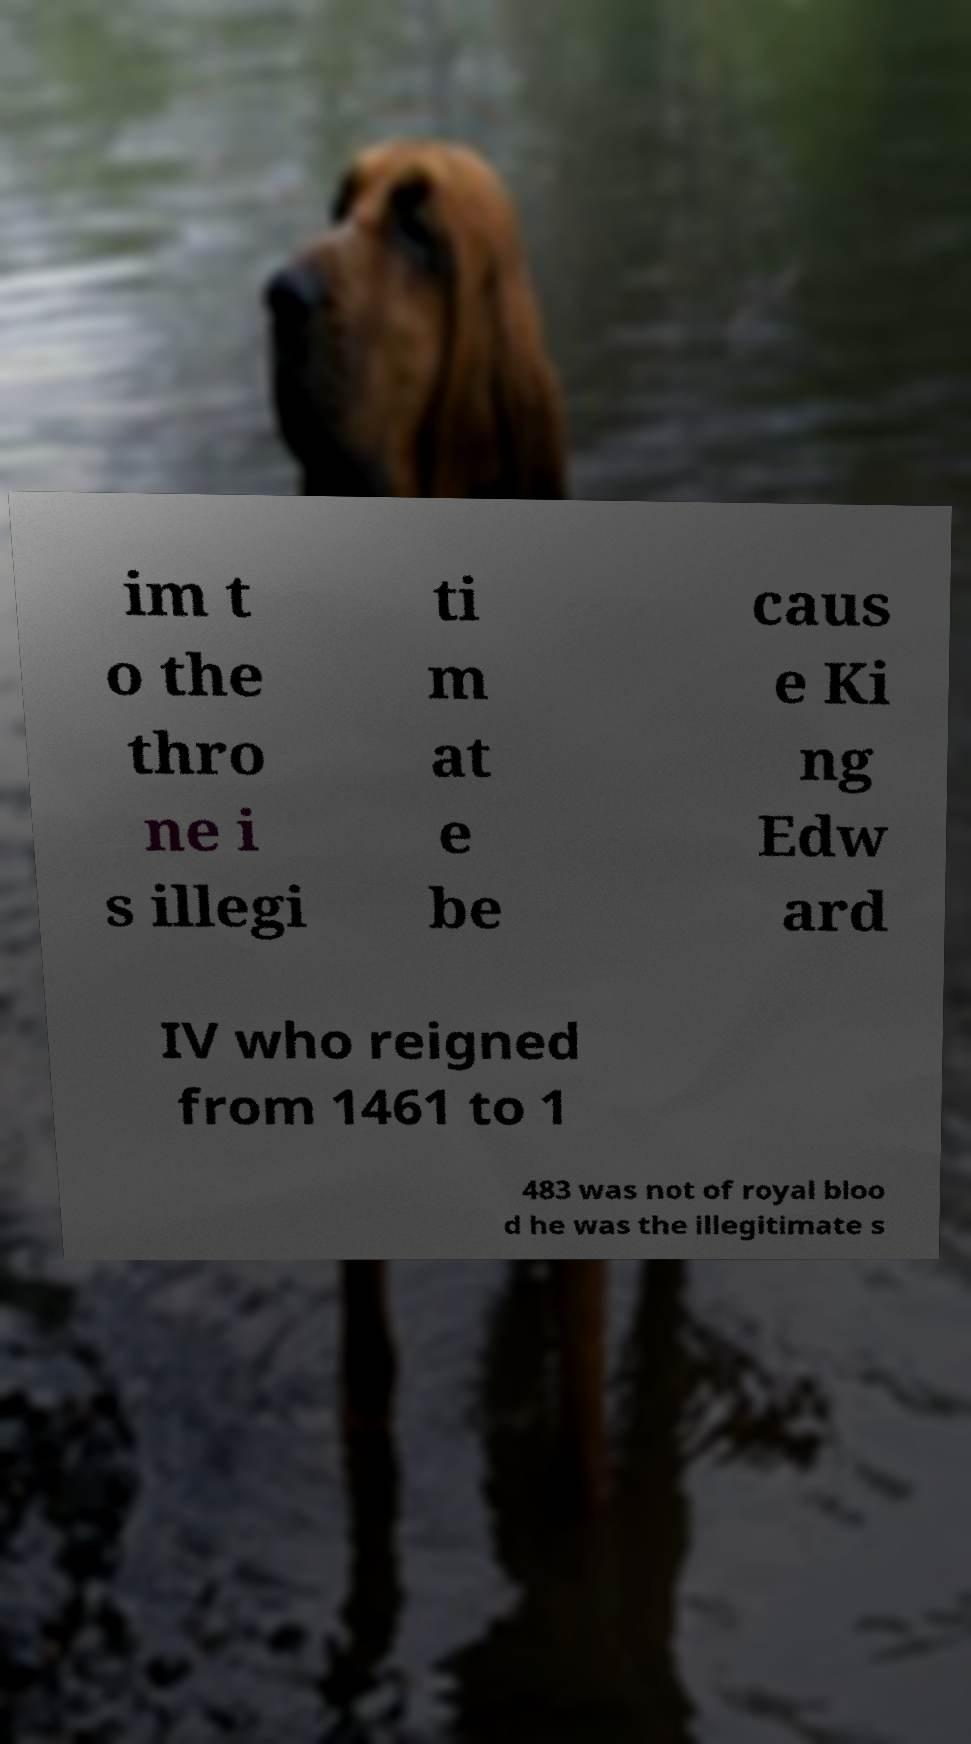Can you accurately transcribe the text from the provided image for me? im t o the thro ne i s illegi ti m at e be caus e Ki ng Edw ard IV who reigned from 1461 to 1 483 was not of royal bloo d he was the illegitimate s 